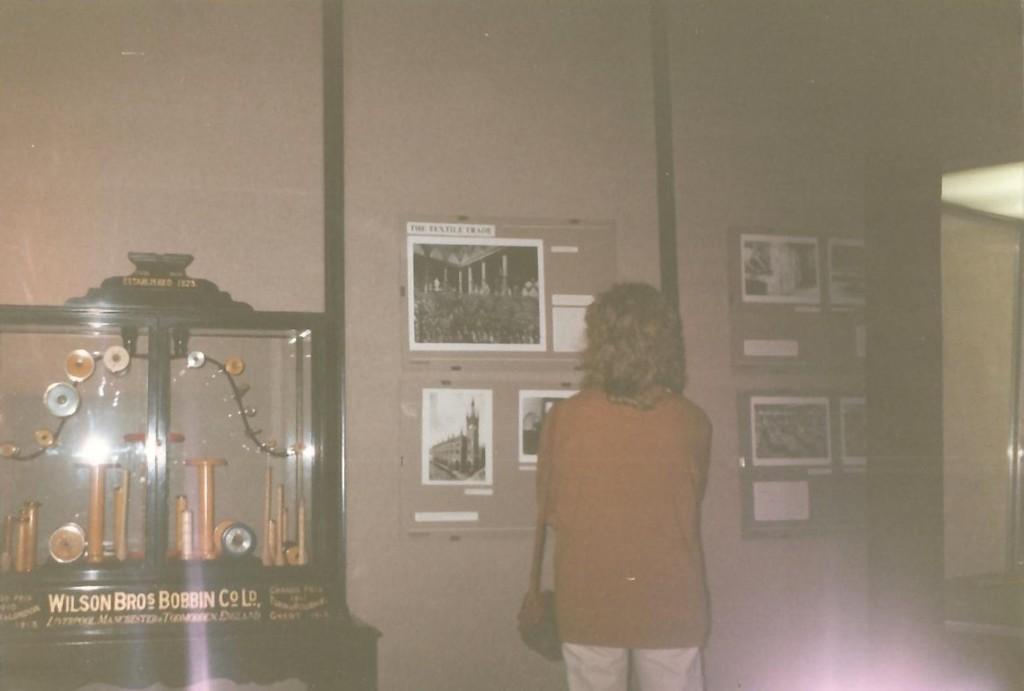Can you describe this image briefly? In this picture we can see notice boards with posters. Here we can see a person standing. This is an equipment with clock timers and other objects. This is a glass. 